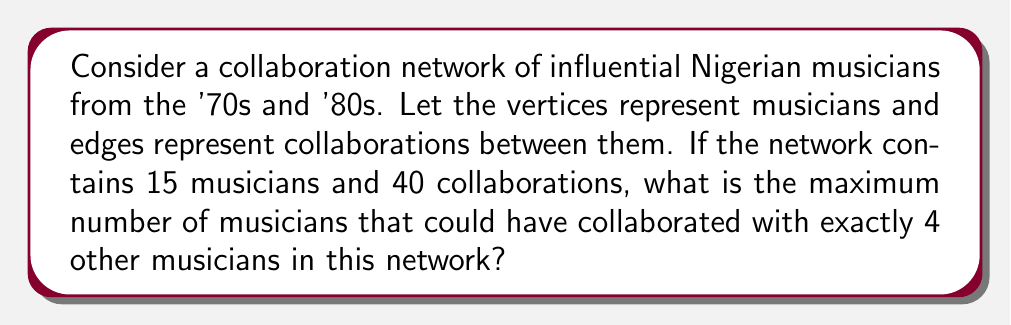Show me your answer to this math problem. To solve this problem, we'll use concepts from graph theory:

1) First, we need to understand what the question is asking. We're looking for the maximum number of vertices (musicians) that could have a degree of 4 in this graph.

2) We know that:
   - The number of vertices $|V| = 15$
   - The number of edges $|E| = 40$

3) In a graph, the sum of all vertex degrees is equal to twice the number of edges. This is because each edge contributes to the degree of two vertices. So:

   $$\sum_{v \in V} \deg(v) = 2|E| = 2(40) = 80$$

4) Let $x$ be the number of vertices with degree 4, and $y$ be the number of vertices with some other degree. Then:

   $$x + y = 15$$

5) The sum of degrees of these $x$ vertices is $4x$. The remaining degree sum must be distributed among the other $y$ vertices. So:

   $$4x + \text{(sum of degrees of other vertices)} = 80$$

6) To maximize $x$, we need to minimize the degrees of the other vertices. The minimum possible degree is 1. So:

   $$4x + y = 80$$

7) Substituting $y = 15 - x$ from step 4:

   $$4x + (15 - x) = 80$$
   $$4x - x + 15 = 80$$
   $$3x = 65$$
   $$x = \frac{65}{3} \approx 21.67$$

8) Since $x$ must be an integer and we're looking for the maximum, we round down to 21.

9) However, we need to check if this is actually possible given our constraints. If we have 21 vertices of degree 4, that would require at least 42 edges, which is more than we have.

10) So we need to reduce $x$ until we satisfy our edge constraint. The largest value of $x$ that works is 10.

11) We can verify: 
    - 10 vertices with degree 4: $10 * 4 = 40$ degree sum
    - 5 vertices with degree 8 (to make up the remaining edges): $5 * 8 = 40$ degree sum
    - Total degree sum: $80 = 2|E|$, which matches our edge count.
Answer: The maximum number of musicians that could have collaborated with exactly 4 other musicians is 10. 